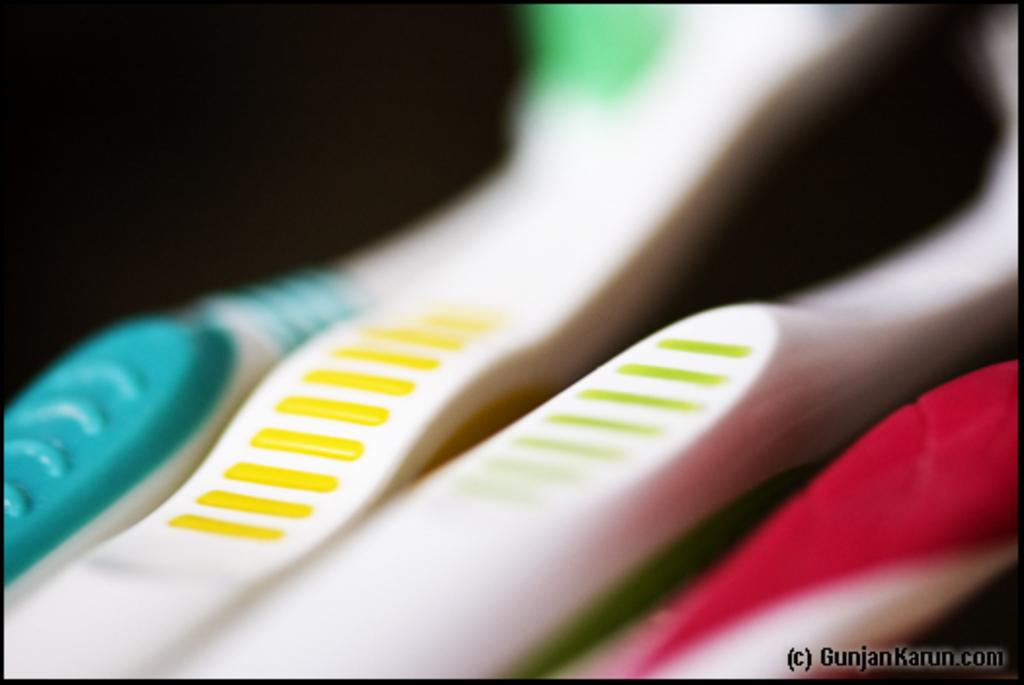How many toothbrushes are visible in the image? There are four toothbrushes in the image. Where are the toothbrushes located in the image? The toothbrushes are on a surface in the image. Are the toothbrushes in the background or foreground of the image? The toothbrushes are in the foreground of the image. How many cherries are on the bike in the image? There is no bike or cherries present in the image. 